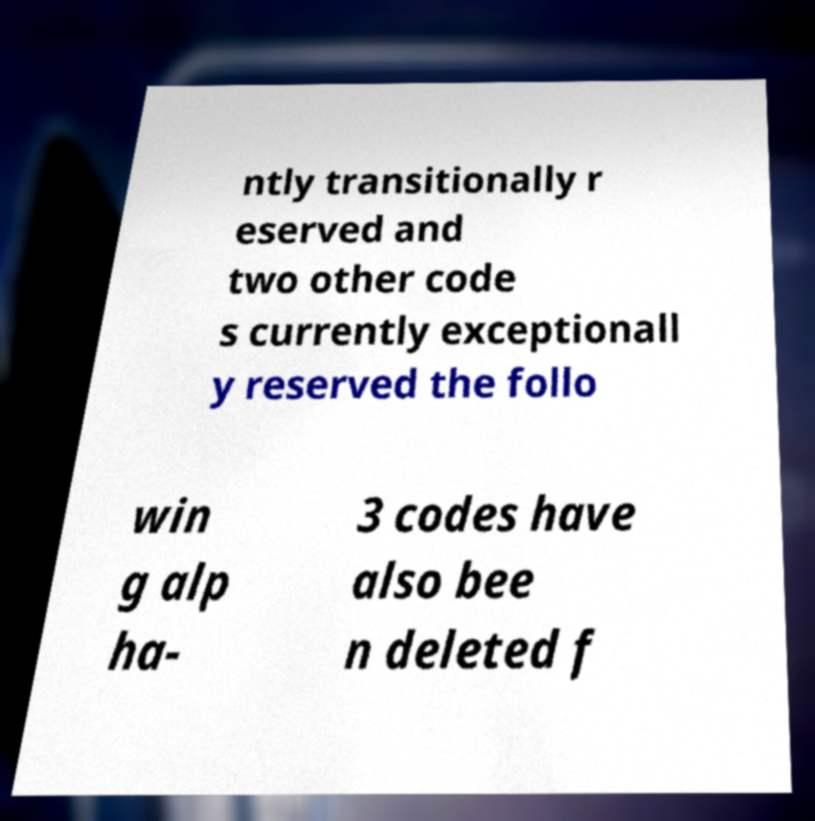For documentation purposes, I need the text within this image transcribed. Could you provide that? ntly transitionally r eserved and two other code s currently exceptionall y reserved the follo win g alp ha- 3 codes have also bee n deleted f 